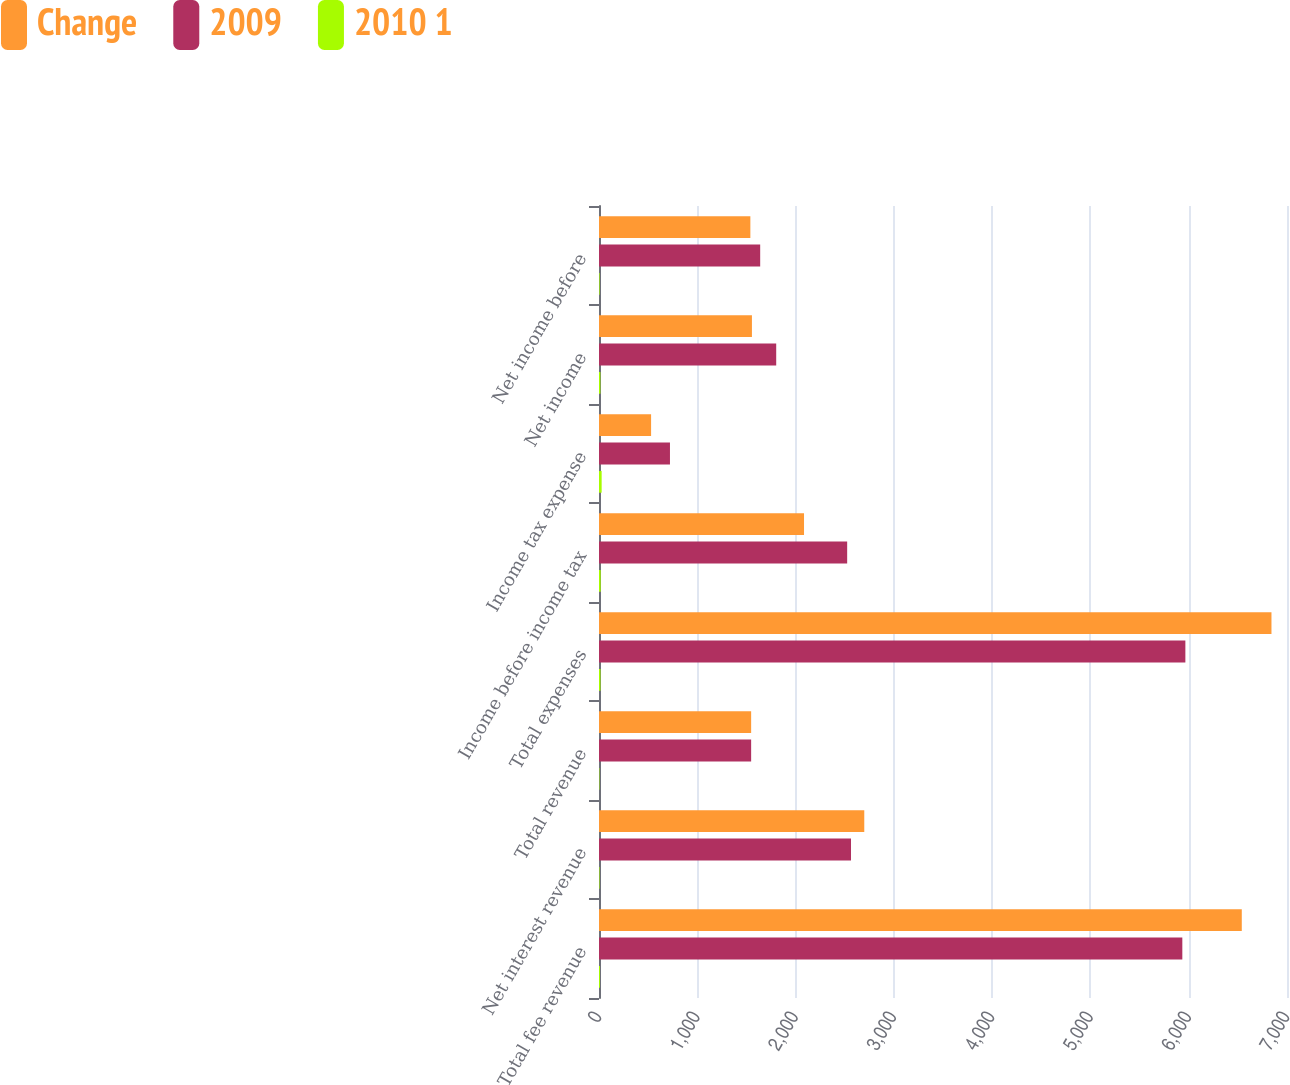Convert chart. <chart><loc_0><loc_0><loc_500><loc_500><stacked_bar_chart><ecel><fcel>Total fee revenue<fcel>Net interest revenue<fcel>Total revenue<fcel>Total expenses<fcel>Income before income tax<fcel>Income tax expense<fcel>Net income<fcel>Net income before<nl><fcel>Change<fcel>6540<fcel>2699<fcel>1548<fcel>6842<fcel>2086<fcel>530<fcel>1556<fcel>1540<nl><fcel>2009<fcel>5935<fcel>2564<fcel>1548<fcel>5966<fcel>2525<fcel>722<fcel>1803<fcel>1640<nl><fcel>2010 1<fcel>10<fcel>5<fcel>4<fcel>15<fcel>17<fcel>27<fcel>14<fcel>6<nl></chart> 